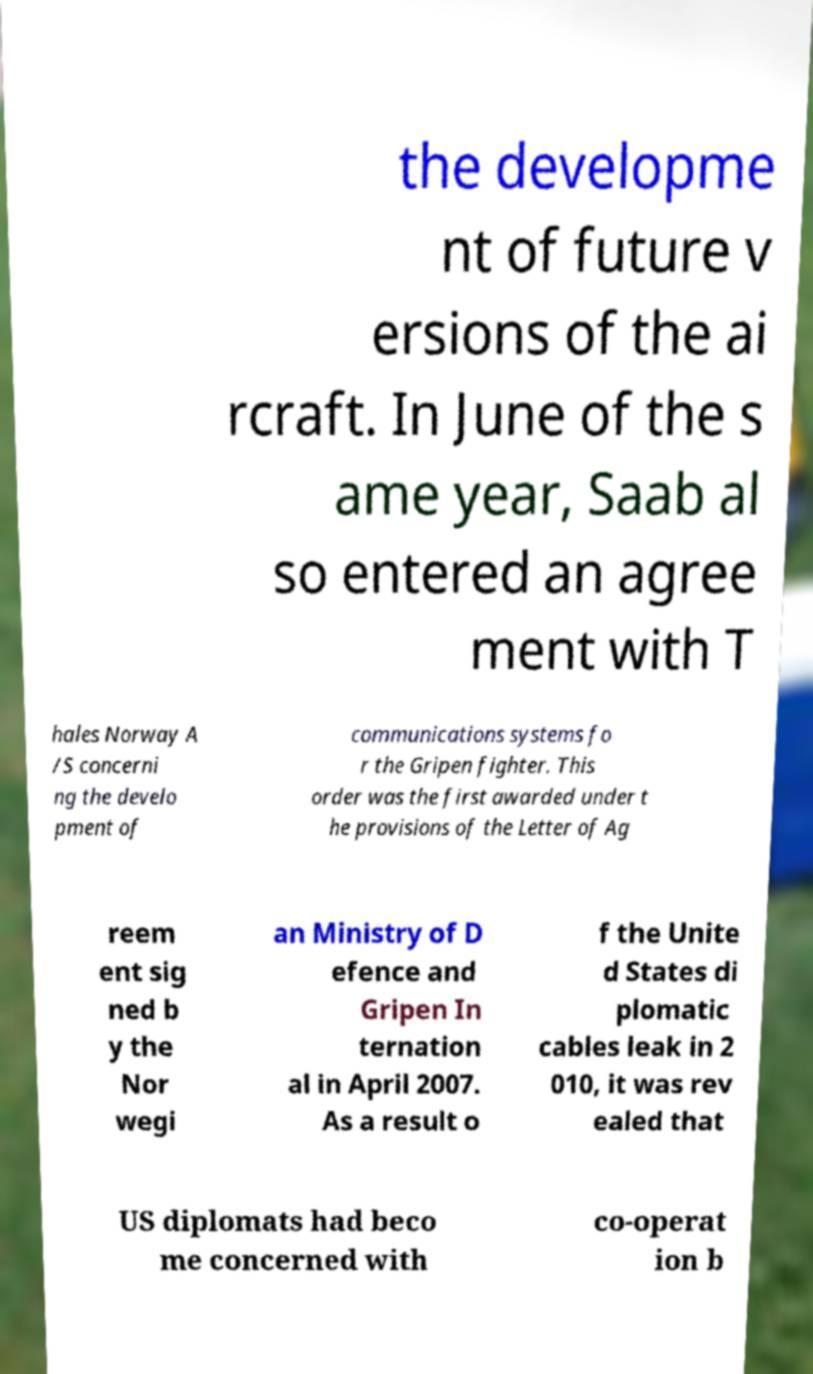What messages or text are displayed in this image? I need them in a readable, typed format. the developme nt of future v ersions of the ai rcraft. In June of the s ame year, Saab al so entered an agree ment with T hales Norway A /S concerni ng the develo pment of communications systems fo r the Gripen fighter. This order was the first awarded under t he provisions of the Letter of Ag reem ent sig ned b y the Nor wegi an Ministry of D efence and Gripen In ternation al in April 2007. As a result o f the Unite d States di plomatic cables leak in 2 010, it was rev ealed that US diplomats had beco me concerned with co-operat ion b 